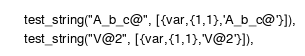Convert code to text. <code><loc_0><loc_0><loc_500><loc_500><_Erlang_>    test_string("A_b_c@", [{var,{1,1},'A_b_c@'}]),
    test_string("V@2", [{var,{1,1},'V@2'}]),</code> 